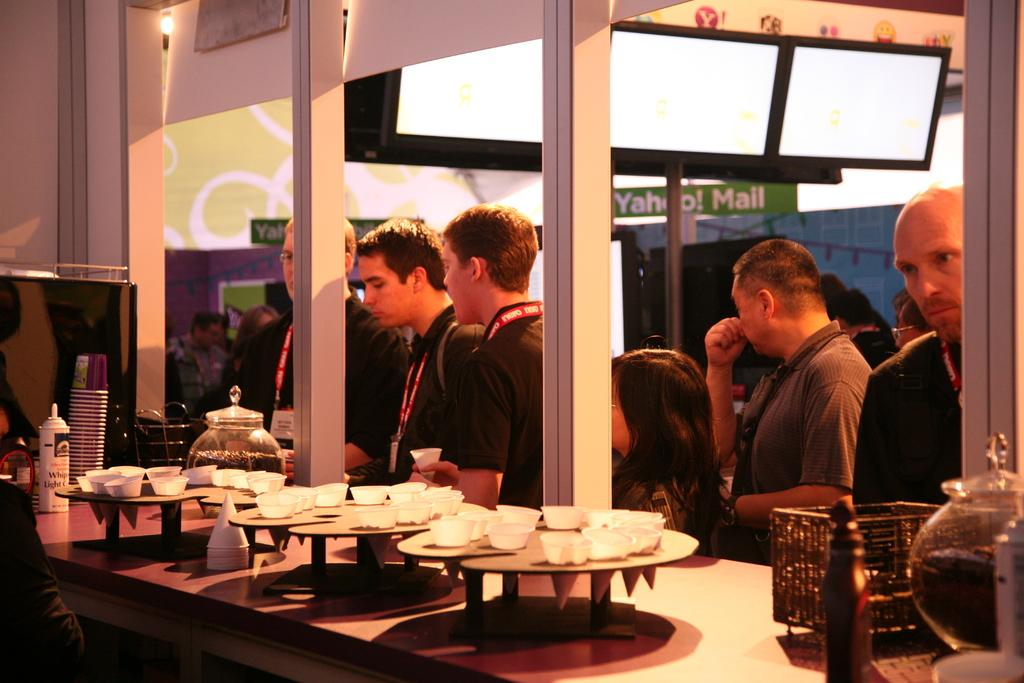What is happening in the image? There are people standing in the image. What objects can be seen in the hands of the people or on a nearby surface? There are cups visible in the image. What type of advertisement is being displayed on the boats in the image? There are no boats present in the image, so there is no advertisement to be displayed on them. 